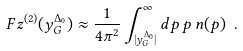<formula> <loc_0><loc_0><loc_500><loc_500>\ F z ^ { ( 2 ) } ( y _ { G } ^ { \Delta _ { 0 } } ) \approx \frac { 1 } { 4 \pi ^ { 2 } } \int _ { | y _ { G } ^ { \Delta _ { 0 } } | } ^ { \infty } d p \, p \, n ( p ) \ .</formula> 